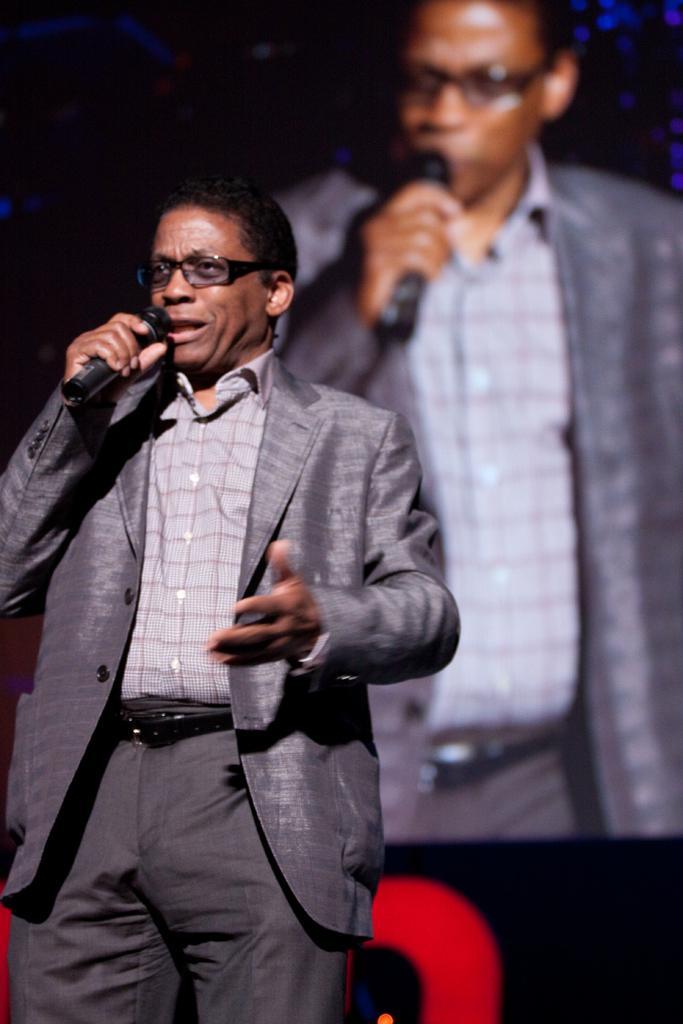Could you give a brief overview of what you see in this image? In the image there is a man wearing grey suit talking on mic. 